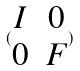Convert formula to latex. <formula><loc_0><loc_0><loc_500><loc_500>( \begin{matrix} I & 0 \\ 0 & F \end{matrix} )</formula> 